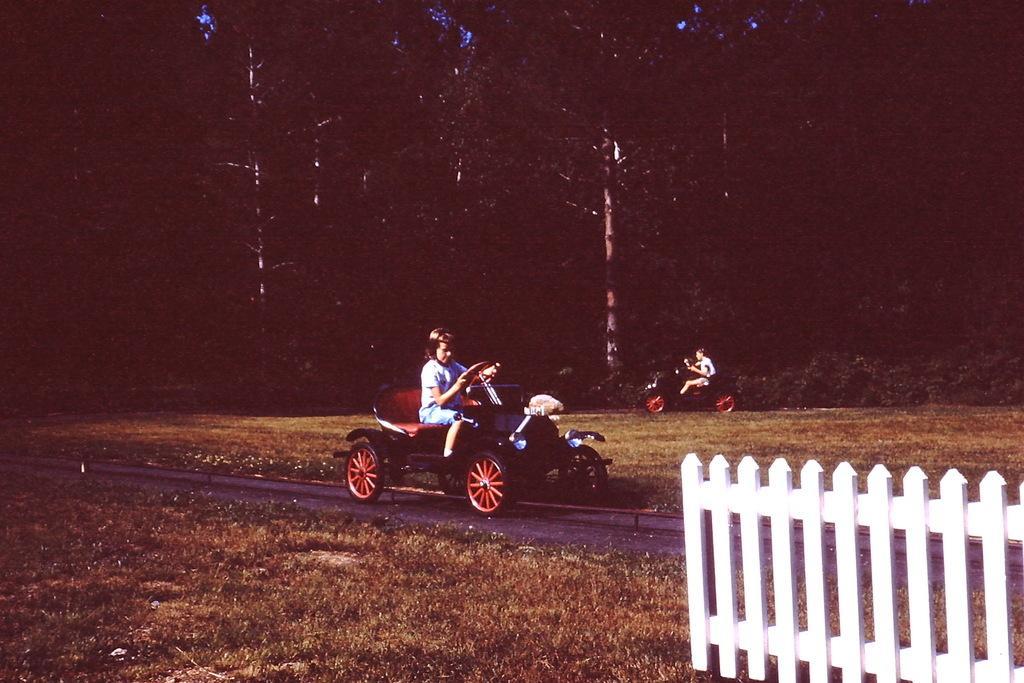Describe this image in one or two sentences. In this image we can see there are people driving a car on the road. And there are trees, grass and fence. 